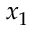Convert formula to latex. <formula><loc_0><loc_0><loc_500><loc_500>x _ { 1 }</formula> 